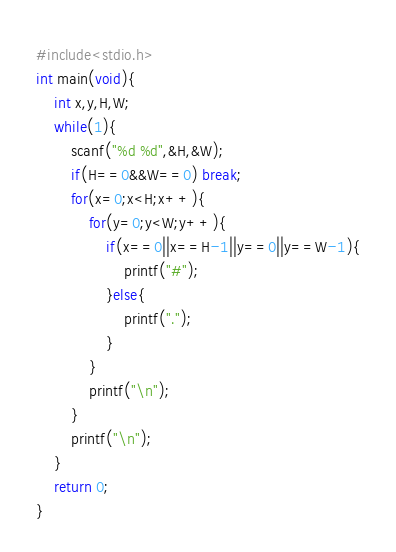Convert code to text. <code><loc_0><loc_0><loc_500><loc_500><_C_>#include<stdio.h>
int main(void){
    int x,y,H,W;
    while(1){
        scanf("%d %d",&H,&W);
        if(H==0&&W==0) break;
        for(x=0;x<H;x++){
            for(y=0;y<W;y++){
                if(x==0||x==H-1||y==0||y==W-1){
                    printf("#");
                }else{
                    printf(".");
                }
            }
            printf("\n");
        }
        printf("\n");
    }
    return 0;
}
</code> 